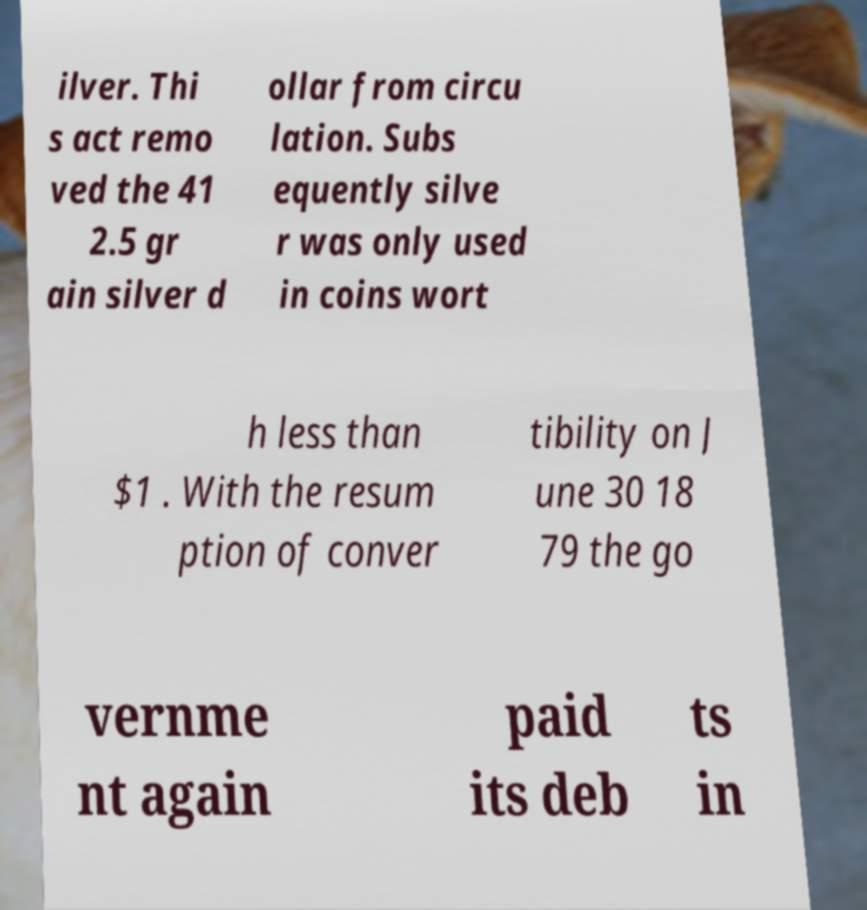I need the written content from this picture converted into text. Can you do that? ilver. Thi s act remo ved the 41 2.5 gr ain silver d ollar from circu lation. Subs equently silve r was only used in coins wort h less than $1 . With the resum ption of conver tibility on J une 30 18 79 the go vernme nt again paid its deb ts in 